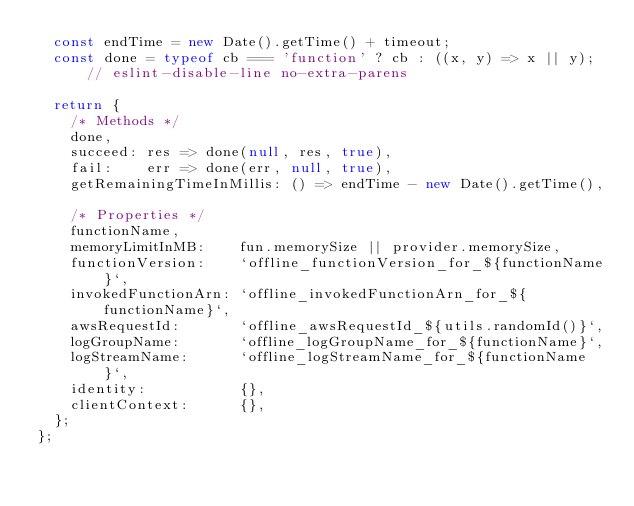Convert code to text. <code><loc_0><loc_0><loc_500><loc_500><_JavaScript_>  const endTime = new Date().getTime() + timeout;
  const done = typeof cb === 'function' ? cb : ((x, y) => x || y); // eslint-disable-line no-extra-parens

  return {
    /* Methods */
    done,
    succeed: res => done(null, res, true),
    fail:    err => done(err, null, true),
    getRemainingTimeInMillis: () => endTime - new Date().getTime(),

    /* Properties */
    functionName,
    memoryLimitInMB:    fun.memorySize || provider.memorySize,
    functionVersion:    `offline_functionVersion_for_${functionName}`,
    invokedFunctionArn: `offline_invokedFunctionArn_for_${functionName}`,
    awsRequestId:       `offline_awsRequestId_${utils.randomId()}`,
    logGroupName:       `offline_logGroupName_for_${functionName}`,
    logStreamName:      `offline_logStreamName_for_${functionName}`,
    identity:           {},
    clientContext:      {},
  };
};
</code> 